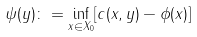<formula> <loc_0><loc_0><loc_500><loc_500>\psi ( y ) \colon = \inf _ { x \in X _ { 0 } } [ c ( x , y ) - \phi ( x ) ]</formula> 